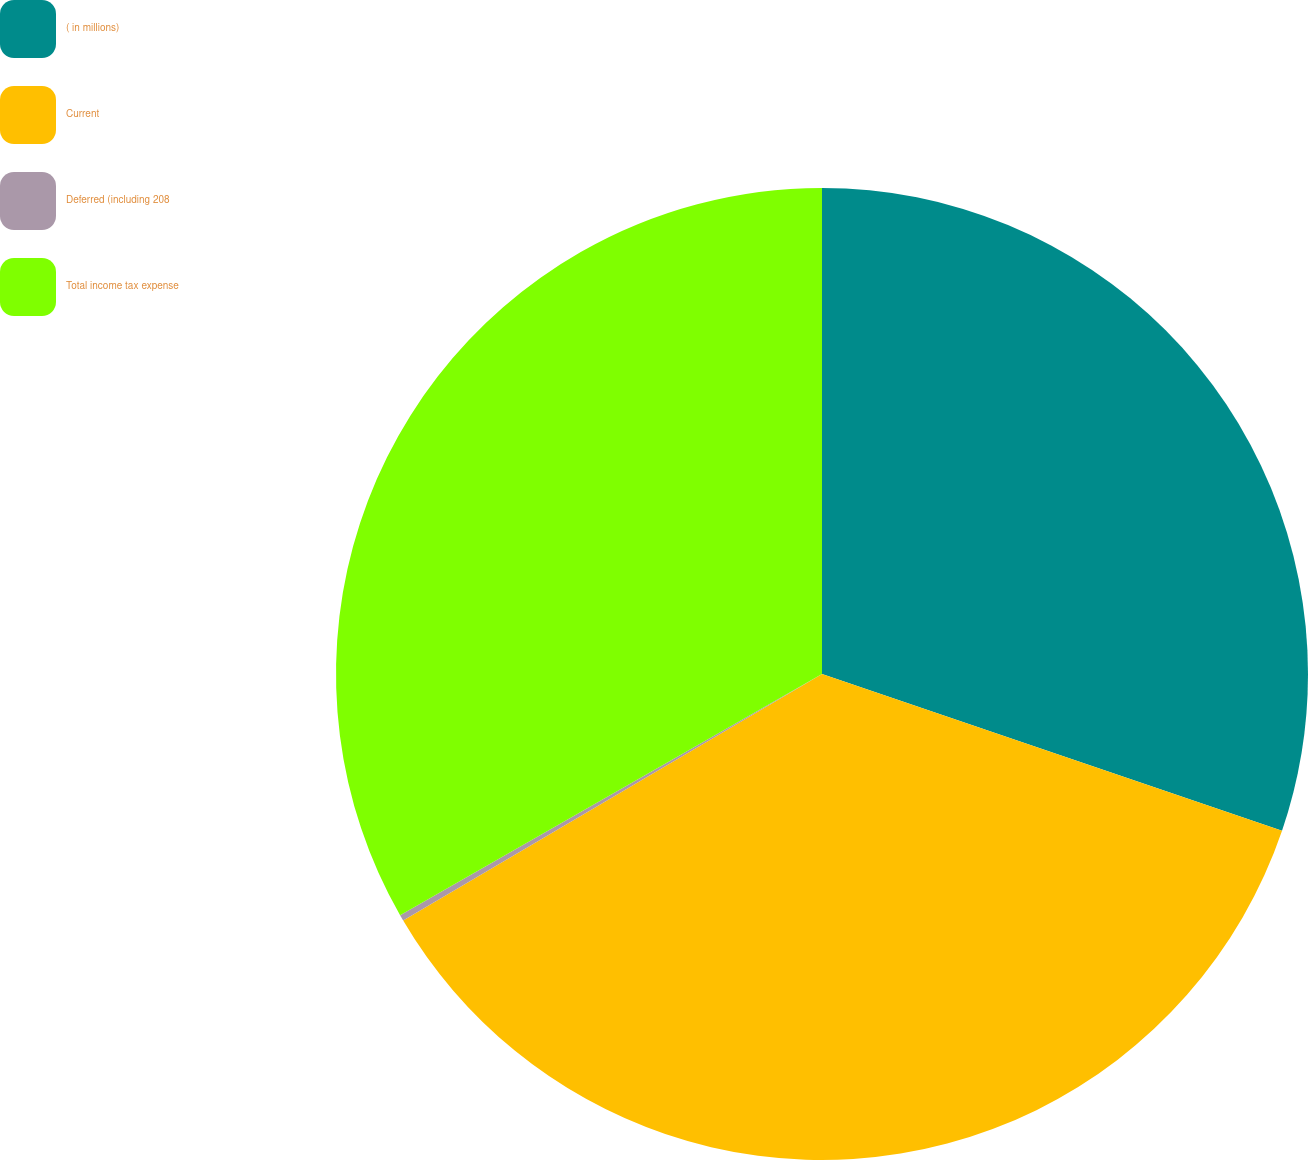Convert chart to OTSL. <chart><loc_0><loc_0><loc_500><loc_500><pie_chart><fcel>( in millions)<fcel>Current<fcel>Deferred (including 208<fcel>Total income tax expense<nl><fcel>30.23%<fcel>36.31%<fcel>0.2%<fcel>33.27%<nl></chart> 